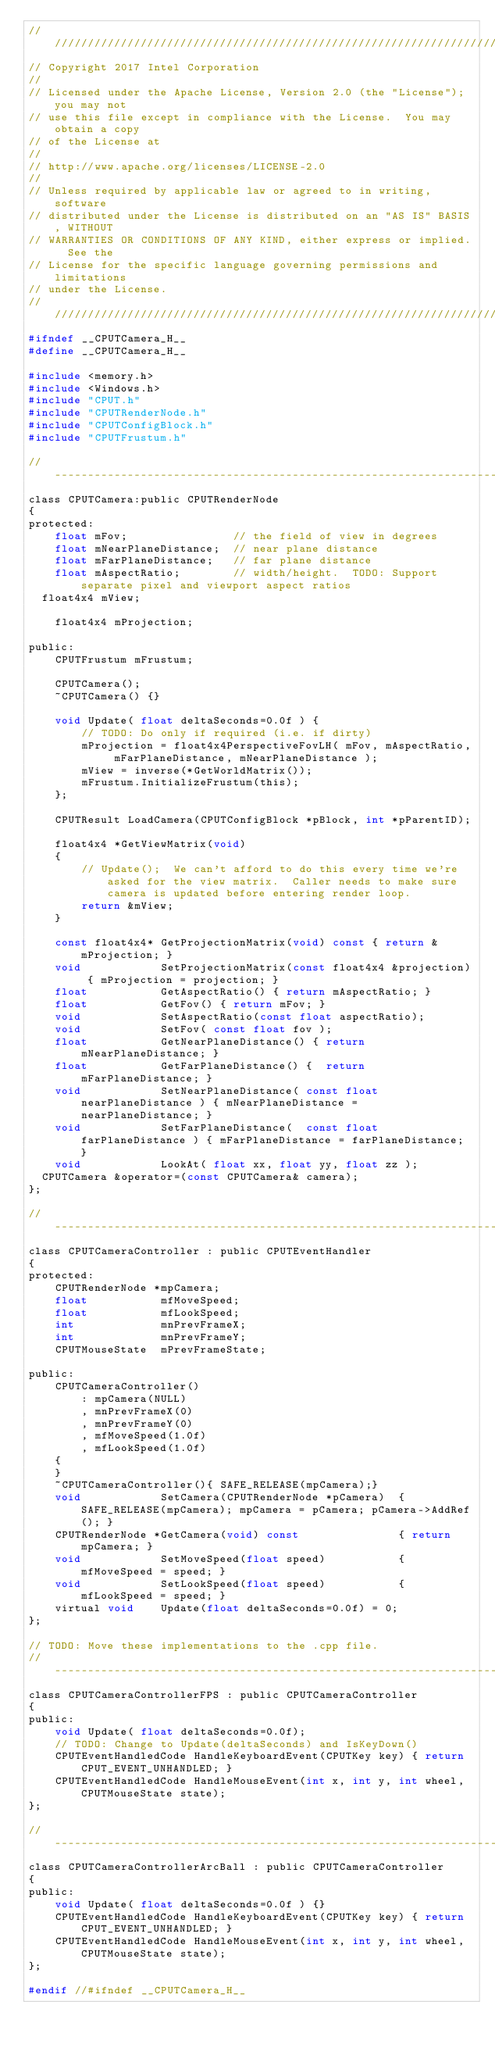Convert code to text. <code><loc_0><loc_0><loc_500><loc_500><_C_>////////////////////////////////////////////////////////////////////////////////
// Copyright 2017 Intel Corporation
//
// Licensed under the Apache License, Version 2.0 (the "License"); you may not
// use this file except in compliance with the License.  You may obtain a copy
// of the License at
//
// http://www.apache.org/licenses/LICENSE-2.0
//
// Unless required by applicable law or agreed to in writing, software
// distributed under the License is distributed on an "AS IS" BASIS, WITHOUT
// WARRANTIES OR CONDITIONS OF ANY KIND, either express or implied.  See the
// License for the specific language governing permissions and limitations
// under the License.
////////////////////////////////////////////////////////////////////////////////
#ifndef __CPUTCamera_H__
#define __CPUTCamera_H__

#include <memory.h>
#include <Windows.h>
#include "CPUT.h"
#include "CPUTRenderNode.h"
#include "CPUTConfigBlock.h"
#include "CPUTFrustum.h"

//-----------------------------------------------------------------------------
class CPUTCamera:public CPUTRenderNode
{
protected:
    float mFov;                // the field of view in degrees
    float mNearPlaneDistance;  // near plane distance
    float mFarPlaneDistance;   // far plane distance
    float mAspectRatio;        // width/height.  TODO: Support separate pixel and viewport aspect ratios
	float4x4 mView;

    float4x4 mProjection;

public:
    CPUTFrustum mFrustum;

    CPUTCamera();
    ~CPUTCamera() {}

    void Update( float deltaSeconds=0.0f ) {
        // TODO: Do only if required (i.e. if dirty)
        mProjection = float4x4PerspectiveFovLH( mFov, mAspectRatio, mFarPlaneDistance, mNearPlaneDistance );
        mView = inverse(*GetWorldMatrix());
        mFrustum.InitializeFrustum(this);
    };

    CPUTResult LoadCamera(CPUTConfigBlock *pBlock, int *pParentID);

    float4x4 *GetViewMatrix(void)
    {
        // Update();  We can't afford to do this every time we're asked for the view matrix.  Caller needs to make sure camera is updated before entering render loop.
        return &mView;
    }

    const float4x4* GetProjectionMatrix(void) const { return &mProjection; }
    void            SetProjectionMatrix(const float4x4 &projection) { mProjection = projection; }
    float           GetAspectRatio() { return mAspectRatio; }
    float           GetFov() { return mFov; }
    void            SetAspectRatio(const float aspectRatio);
    void            SetFov( const float fov );
    float           GetNearPlaneDistance() { return mNearPlaneDistance; }
    float           GetFarPlaneDistance() {  return mFarPlaneDistance; }
    void            SetNearPlaneDistance( const float nearPlaneDistance ) { mNearPlaneDistance = nearPlaneDistance; }
    void            SetFarPlaneDistance(  const float farPlaneDistance ) { mFarPlaneDistance = farPlaneDistance; }
    void            LookAt( float xx, float yy, float zz );
	CPUTCamera &operator=(const CPUTCamera& camera);
};

//-----------------------------------------------------------------------------
class CPUTCameraController : public CPUTEventHandler
{
protected:
    CPUTRenderNode *mpCamera;
    float           mfMoveSpeed;
    float           mfLookSpeed;
    int             mnPrevFrameX;
    int             mnPrevFrameY;
    CPUTMouseState  mPrevFrameState;

public:
    CPUTCameraController()
        : mpCamera(NULL)
        , mnPrevFrameX(0)
        , mnPrevFrameY(0)
        , mfMoveSpeed(1.0f)
        , mfLookSpeed(1.0f)
    {
    }
    ~CPUTCameraController(){ SAFE_RELEASE(mpCamera);}
    void            SetCamera(CPUTRenderNode *pCamera)  { SAFE_RELEASE(mpCamera); mpCamera = pCamera; pCamera->AddRef(); }
    CPUTRenderNode *GetCamera(void) const               { return mpCamera; }
    void            SetMoveSpeed(float speed)           { mfMoveSpeed = speed; }
    void            SetLookSpeed(float speed)           { mfLookSpeed = speed; }
    virtual void    Update(float deltaSeconds=0.0f) = 0;
};

// TODO: Move these implementations to the .cpp file.
//-----------------------------------------------------------------------------
class CPUTCameraControllerFPS : public CPUTCameraController
{
public:
    void Update( float deltaSeconds=0.0f);
    // TODO: Change to Update(deltaSeconds) and IsKeyDown()
    CPUTEventHandledCode HandleKeyboardEvent(CPUTKey key) { return CPUT_EVENT_UNHANDLED; }
    CPUTEventHandledCode HandleMouseEvent(int x, int y, int wheel, CPUTMouseState state);
};

//-----------------------------------------------------------------------------
class CPUTCameraControllerArcBall : public CPUTCameraController
{
public:
    void Update( float deltaSeconds=0.0f ) {}
    CPUTEventHandledCode HandleKeyboardEvent(CPUTKey key) { return CPUT_EVENT_UNHANDLED; }
    CPUTEventHandledCode HandleMouseEvent(int x, int y, int wheel, CPUTMouseState state);
};

#endif //#ifndef __CPUTCamera_H__
</code> 